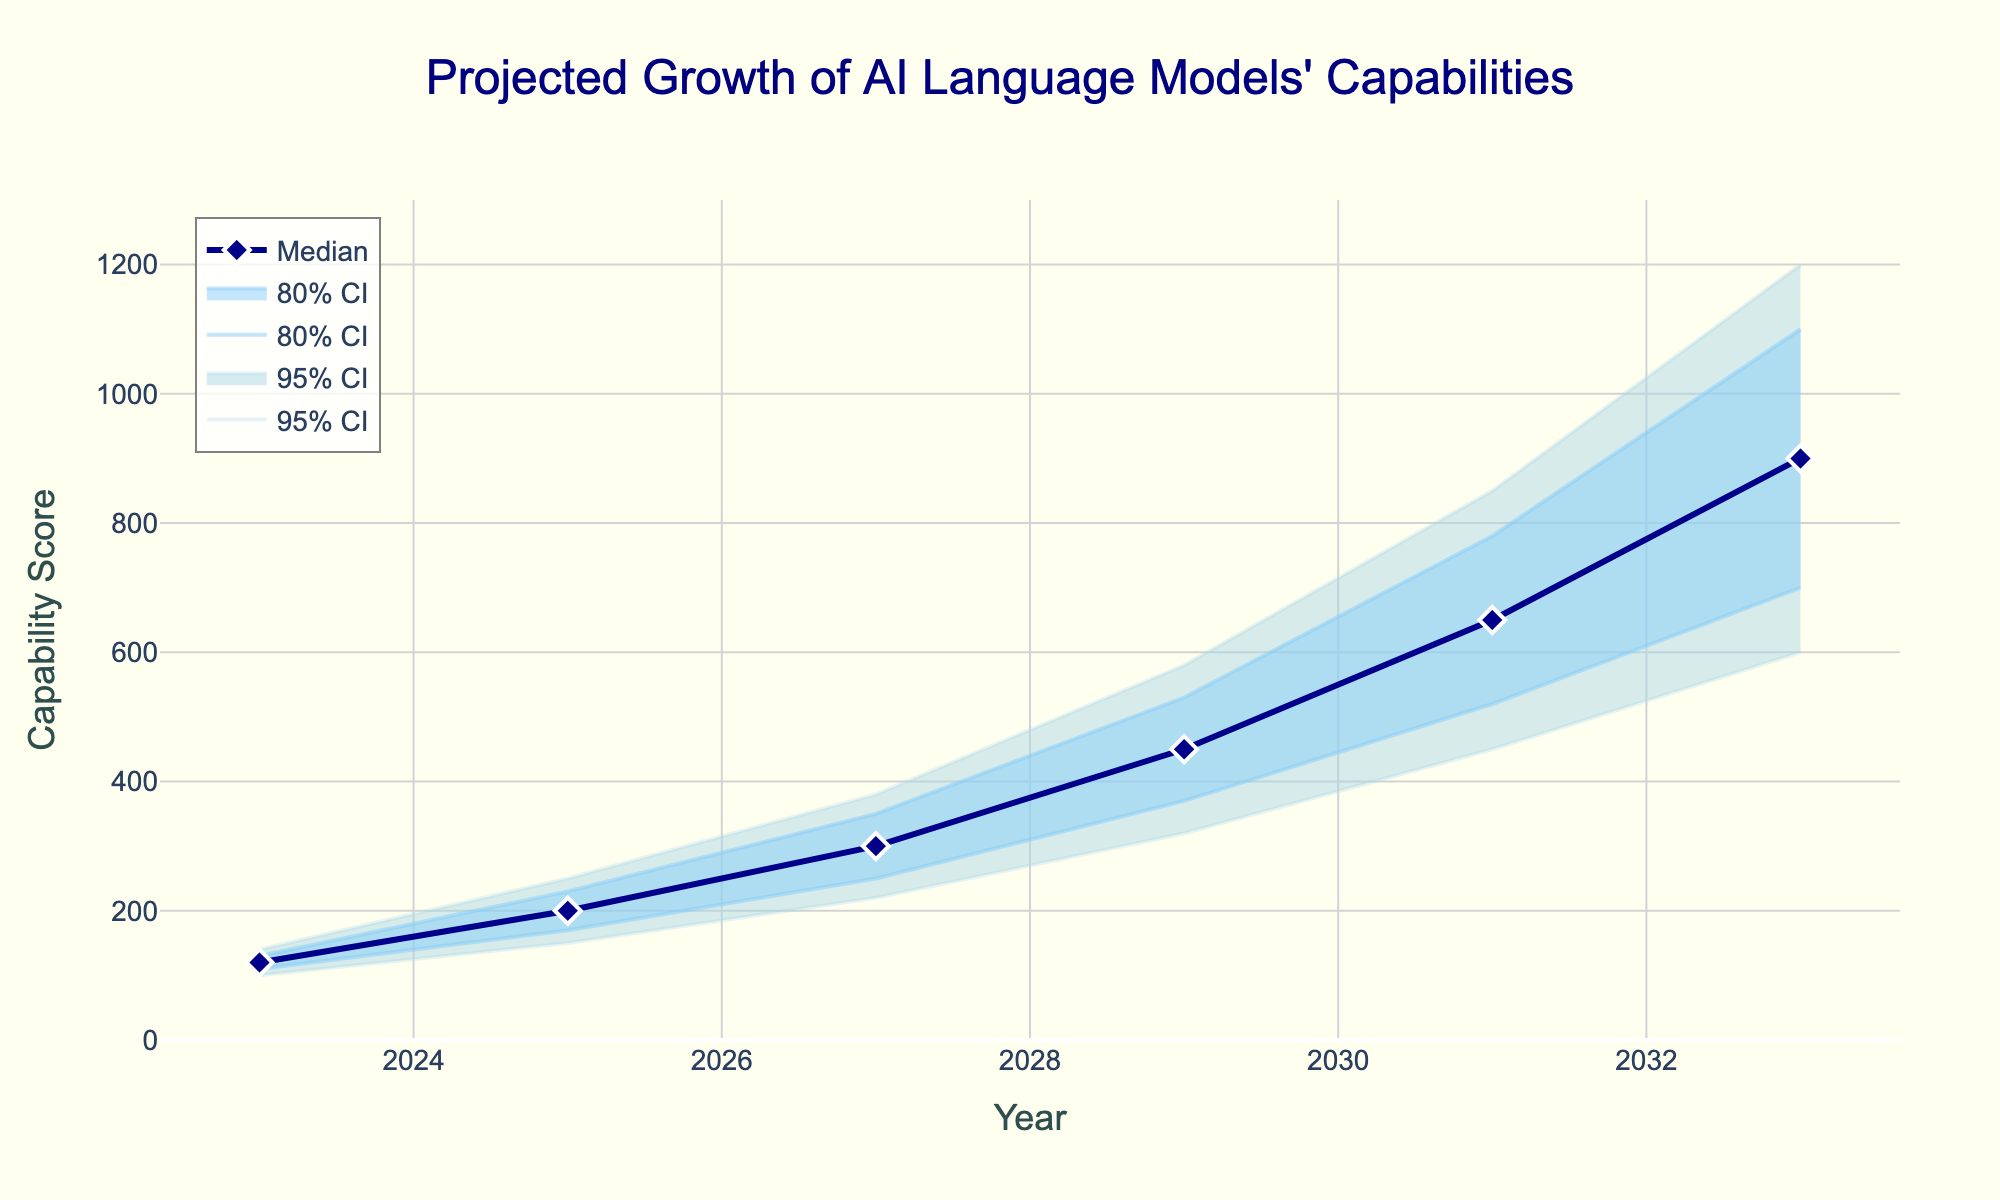What is the title of the plot? The title is located at the top center of the plot area and is used to describe the main topic of the figure.
Answer: Projected Growth of AI Language Models' Capabilities What is the median capability score projected for the year 2027? To find the median score for a specific year, look at the value of the "Median" line for that year.
Answer: 300 Which year has the widest range in the 95% confidence interval? The 95% confidence interval ranges are represented by the lightest blue shaded area. The widest range is the difference between the upper and lower bounds for the given years. The range in 2029 is the largest at 580 - 320 = 260.
Answer: 2029 How many years are displayed on the x-axis? Count the distinct tick marks or data points along the x-axis that represent different years.
Answer: 6 What is the upper 80% confidence interval value for the year 2033? Locate the 80% confidence interval on the plot for 2033 and read the upper boundary value.
Answer: 1100 By how much is the projected median capability score in 2033 higher than in 2025? Subtract the projected median value in 2025 from the projected median value in 2033: 900 - 200 = 700.
Answer: 700 What is the projected lower 80% confidence interval value for the year 2031? Locate the 80% confidence interval on the plot for 2031 and read the lower boundary value.
Answer: 520 How does the upper 95% confidence interval in 2029 compare to the median value in 2031? Compare the upper boundary of the 95% CI for 2029 with the median value for 2031: Upper 95% CI in 2029 is 580, and median in 2031 is 650.
Answer: The median in 2031 is higher What trends can be observed in the median values over the years? Analyzing the progression of the median line, note that it shows a consistent upward trend from 2023 to 2033.
Answer: The median values consistently increase What is the color representing the median capability score line? The median line color can be identified by locating the legend or observing the line itself.
Answer: Dark blue 